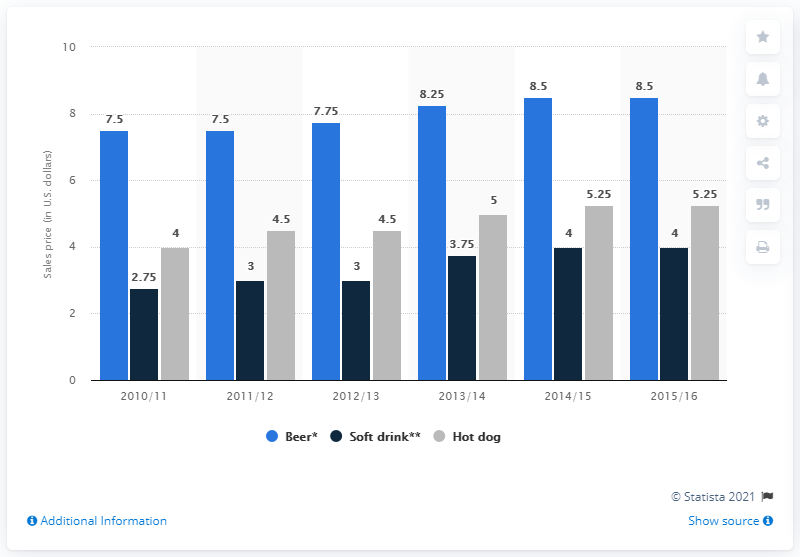Draw attention to some important aspects in this diagram. The average sales price of a hot dog at Philadelphia 76ers games from 2013/14 to 2014/15 was 5.125 dollars. In the 2015/16 season, the sales price of beer at Philadelphia 76ers games was 8.5 USD. In the 2012/2013 season, a 12-ounce beer typically cost 7.75. 